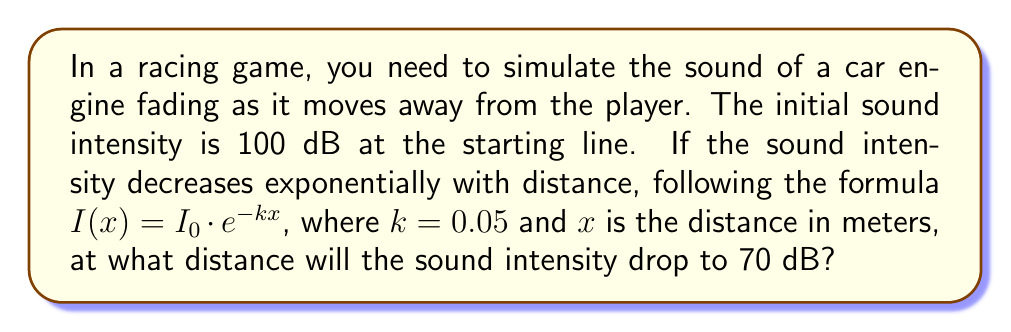Help me with this question. To solve this problem, we'll use the exponential decay formula and follow these steps:

1) The given formula is $I(x) = I_0 \cdot e^{-kx}$, where:
   $I(x)$ is the intensity at distance $x$
   $I_0$ is the initial intensity
   $k$ is the decay constant (0.05 in this case)
   $x$ is the distance in meters

2) We know:
   $I_0 = 100$ dB
   $I(x) = 70$ dB (the intensity we want to find the distance for)
   $k = 0.05$

3) Let's substitute these values into the formula:
   $70 = 100 \cdot e^{-0.05x}$

4) Divide both sides by 100:
   $0.7 = e^{-0.05x}$

5) Take the natural logarithm of both sides:
   $\ln(0.7) = \ln(e^{-0.05x})$

6) Simplify the right side using the properties of logarithms:
   $\ln(0.7) = -0.05x$

7) Divide both sides by -0.05:
   $\frac{\ln(0.7)}{-0.05} = x$

8) Calculate the value:
   $x \approx 71.08$ meters

Therefore, the sound intensity will drop to 70 dB at approximately 71.08 meters from the starting line.
Answer: 71.08 meters 